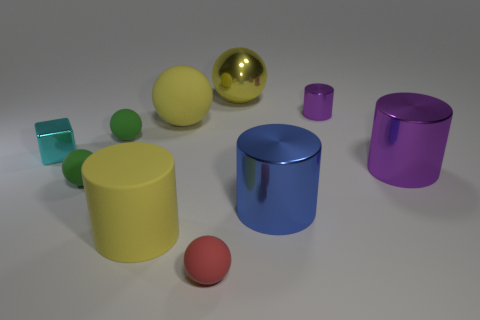Subtract all purple cylinders. How many were subtracted if there are1purple cylinders left? 1 Subtract all red spheres. How many spheres are left? 4 Subtract all big matte balls. How many balls are left? 4 Subtract all purple balls. Subtract all blue cubes. How many balls are left? 5 Subtract all cylinders. How many objects are left? 6 Add 8 small yellow matte blocks. How many small yellow matte blocks exist? 8 Subtract 0 gray cubes. How many objects are left? 10 Subtract all tiny cubes. Subtract all tiny cyan shiny things. How many objects are left? 8 Add 1 large yellow shiny objects. How many large yellow shiny objects are left? 2 